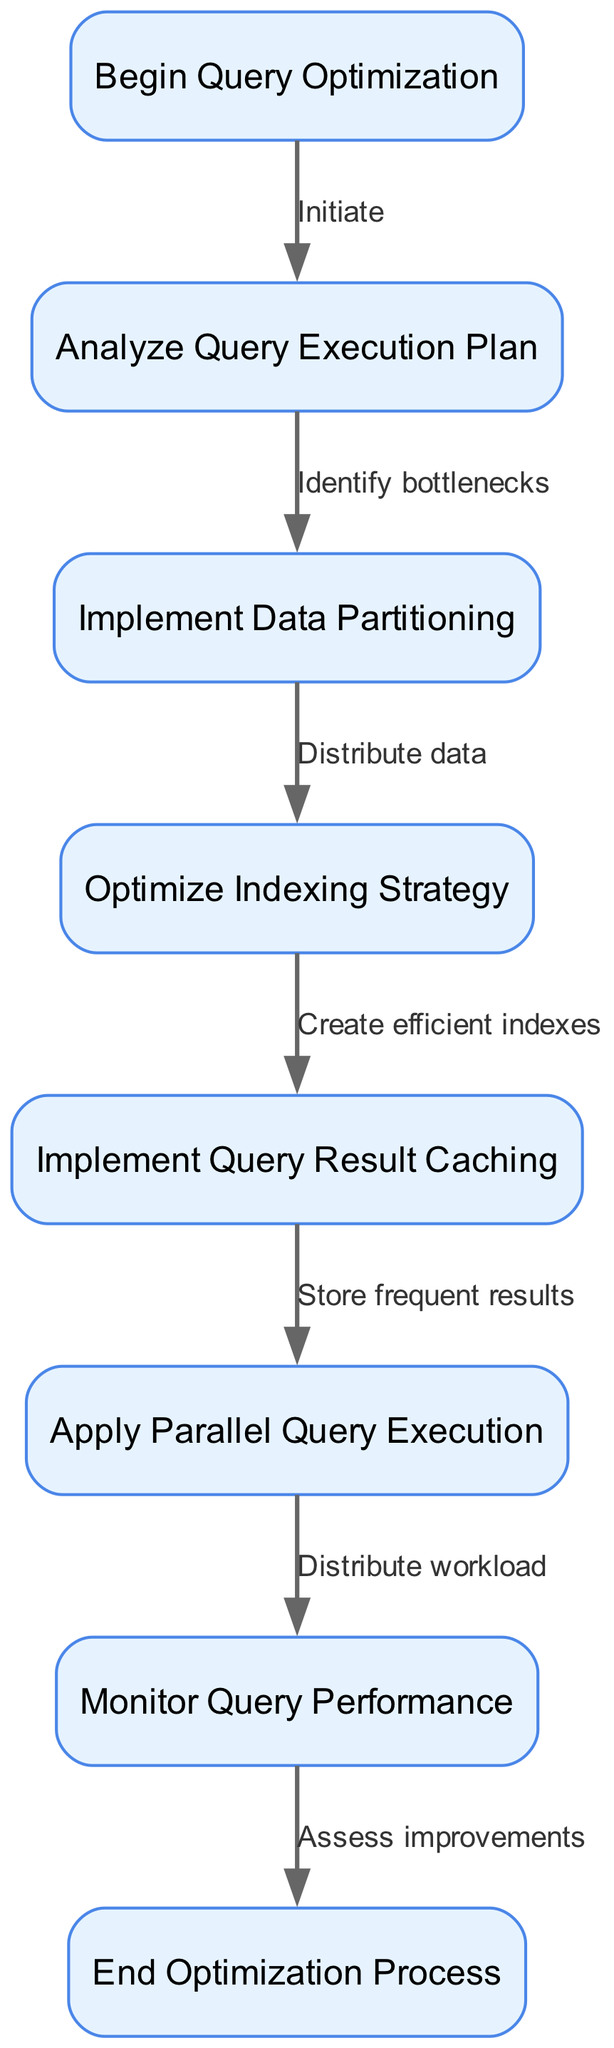What is the first step in the flowchart? The flowchart begins with the node labeled "Begin Query Optimization," which initiates the optimization process. This is the starting point before any analysis or actions are taken.
Answer: Begin Query Optimization How many nodes are there in the flowchart? By counting the individual nodes listed in the diagram, we find there are eight distinct nodes representing various stages in the query optimization process.
Answer: Eight What is the last step of the optimization process? The flowchart concludes with the node labeled "End Optimization Process," which signifies the completion of the optimization sequence.
Answer: End Optimization Process What action follows the analysis of the query execution plan? After "Analyze Query Execution Plan," the next action indicated in the flowchart is "Implement Data Partitioning," which suggests addressing any identified bottlenecks.
Answer: Implement Data Partitioning How do the nodes "Optimize Indexing Strategy" and "Implement Query Result Caching" relate? The flowchart shows that after optimizing the indexing strategy, the next step is to implement query result caching, indicating a sequential relationship where indexing improves query cache effectiveness.
Answer: Sequential relationship What must be done before applying parallel query execution? The flowchart dictates that one must first "Implement Query Result Caching" before moving to "Apply Parallel Query Execution," illustrating a logical progression in optimizing query processes.
Answer: Implement Query Result Caching In the flowchart, how is performance assessed? The performance is assessed following the "Monitor Query Performance" node, leading directly to the end of the optimization process, which indicates that monitoring is essential for evaluating improvements made.
Answer: Monitor Query Performance Which action is taken after distributing data? After the step "Distribute data" in the flowchart, the next action taken is "Optimize Indexing Strategy," suggesting the need for indexing adjustments post-partitioning.
Answer: Optimize Indexing Strategy How is workload handled in the optimization process? The workload is handled by "Applying Parallel Query Execution" as indicated in the diagram, which emphasizes the distribution of the query workload across multiple processes or nodes.
Answer: Apply Parallel Query Execution 